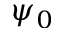Convert formula to latex. <formula><loc_0><loc_0><loc_500><loc_500>\psi _ { 0 }</formula> 